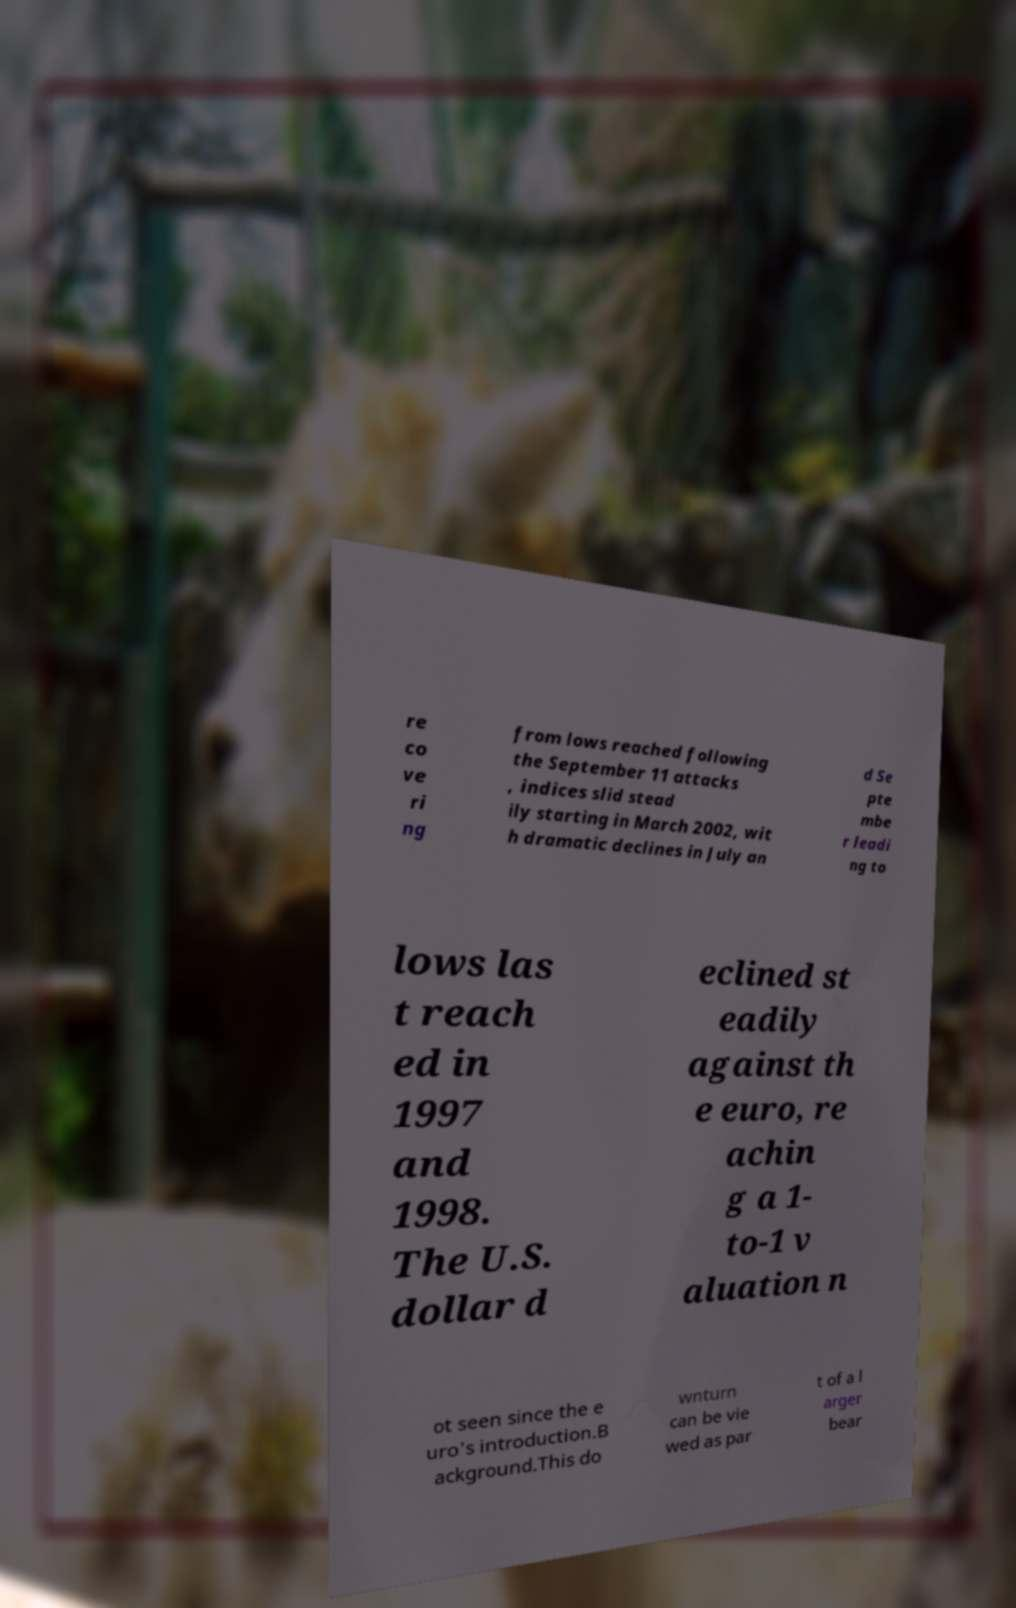Can you read and provide the text displayed in the image?This photo seems to have some interesting text. Can you extract and type it out for me? re co ve ri ng from lows reached following the September 11 attacks , indices slid stead ily starting in March 2002, wit h dramatic declines in July an d Se pte mbe r leadi ng to lows las t reach ed in 1997 and 1998. The U.S. dollar d eclined st eadily against th e euro, re achin g a 1- to-1 v aluation n ot seen since the e uro's introduction.B ackground.This do wnturn can be vie wed as par t of a l arger bear 